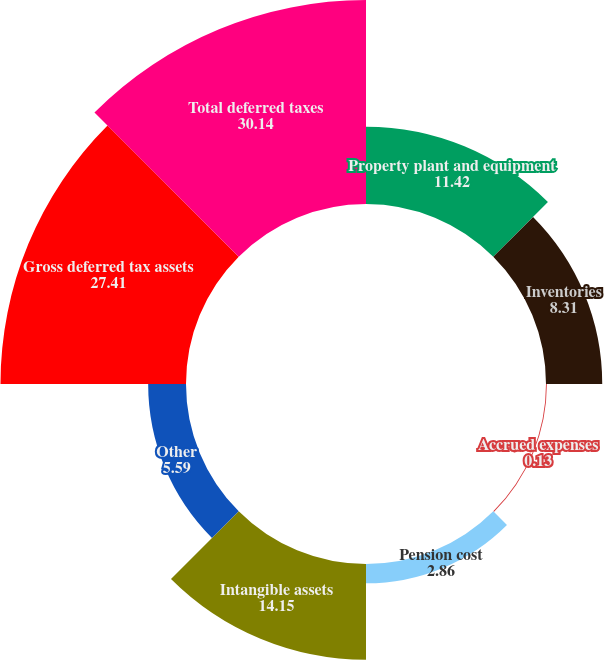Convert chart to OTSL. <chart><loc_0><loc_0><loc_500><loc_500><pie_chart><fcel>Property plant and equipment<fcel>Inventories<fcel>Accrued expenses<fcel>Pension cost<fcel>Intangible assets<fcel>Other<fcel>Gross deferred tax assets<fcel>Total deferred taxes<nl><fcel>11.42%<fcel>8.31%<fcel>0.13%<fcel>2.86%<fcel>14.15%<fcel>5.59%<fcel>27.41%<fcel>30.14%<nl></chart> 